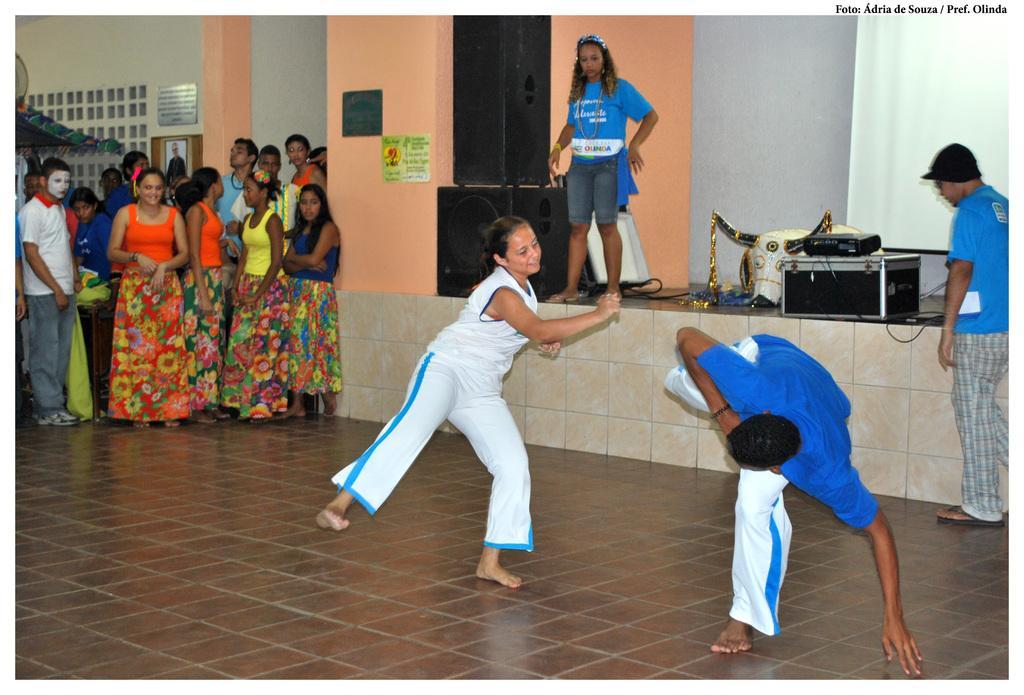How would you summarize this image in a sentence or two? In the middle of the image, there are two persons doing a performance on the floor. On the left side, there are persons in different color dresses watching them. On the right side, there is a person standing. In the background, there is a woman standing, on which there are speakers and other devices and there is a wall. 